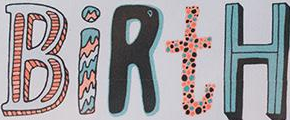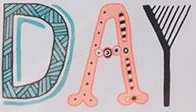What words are shown in these images in order, separated by a semicolon? BiRtH; DAY 